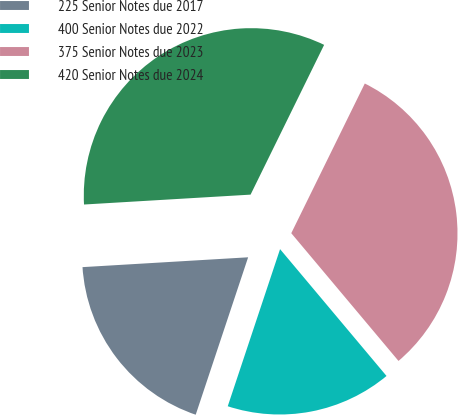Convert chart. <chart><loc_0><loc_0><loc_500><loc_500><pie_chart><fcel>225 Senior Notes due 2017<fcel>400 Senior Notes due 2022<fcel>375 Senior Notes due 2023<fcel>420 Senior Notes due 2024<nl><fcel>18.94%<fcel>16.23%<fcel>31.62%<fcel>33.21%<nl></chart> 